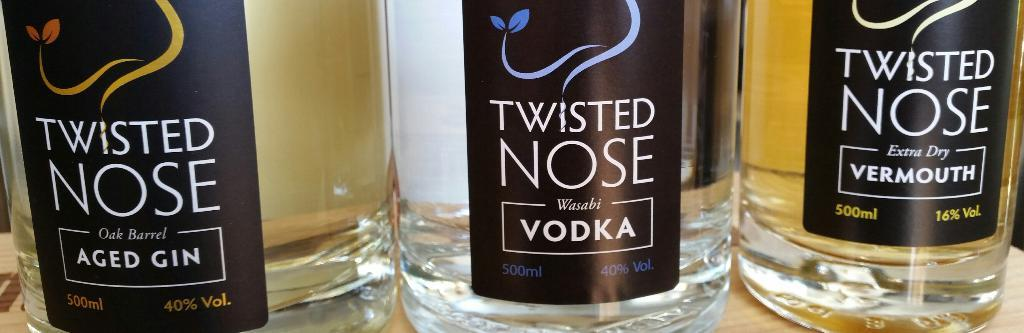Provide a one-sentence caption for the provided image. Three bottles of Twisted Nose alcohol are lined up next to each other. 